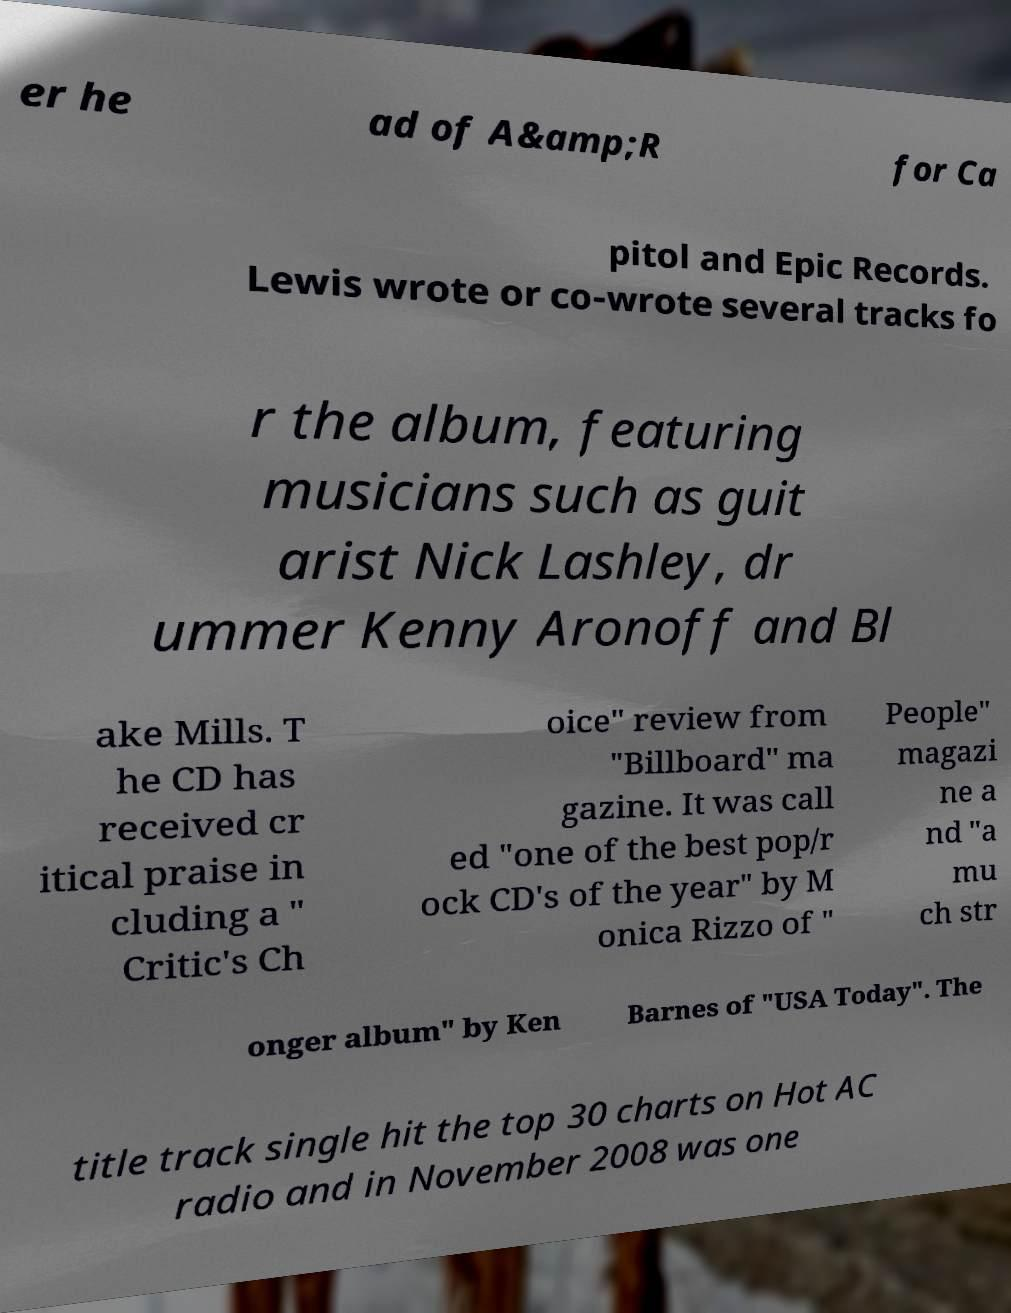Could you extract and type out the text from this image? er he ad of A&amp;R for Ca pitol and Epic Records. Lewis wrote or co-wrote several tracks fo r the album, featuring musicians such as guit arist Nick Lashley, dr ummer Kenny Aronoff and Bl ake Mills. T he CD has received cr itical praise in cluding a " Critic's Ch oice" review from "Billboard" ma gazine. It was call ed "one of the best pop/r ock CD's of the year" by M onica Rizzo of " People" magazi ne a nd "a mu ch str onger album" by Ken Barnes of "USA Today". The title track single hit the top 30 charts on Hot AC radio and in November 2008 was one 